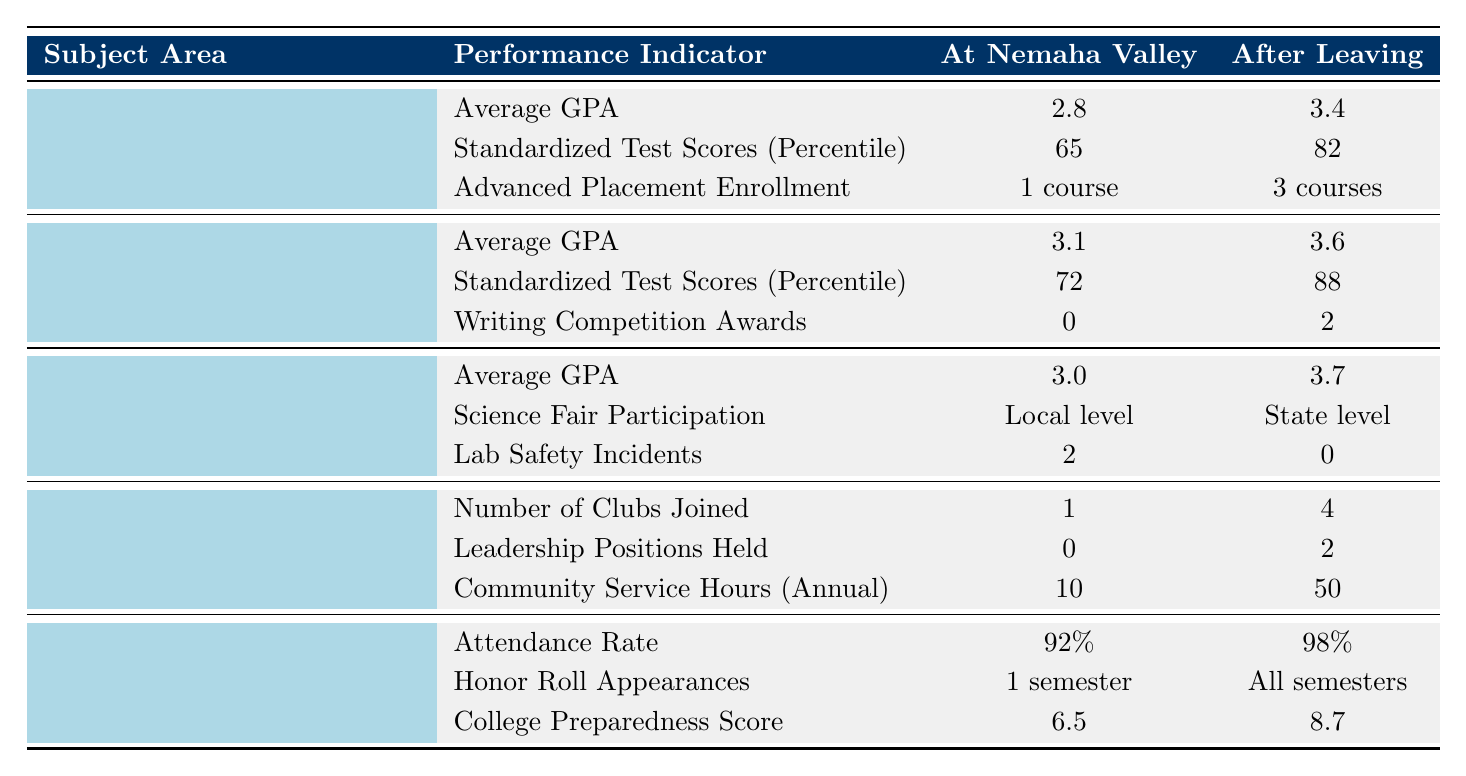What was the Average GPA in Mathematics at Nemaha Valley Schools? The table shows that the Average GPA in Mathematics at Nemaha Valley Schools was 2.8.
Answer: 2.8 What is the percentage increase in Standardized Test Scores for English Language Arts after leaving Nemaha Valley? The scores were 72 at Nemaha Valley and 88 after leaving. The difference is 88 - 72 = 16. The percentage increase is (16 / 72) * 100 = 22.22%.
Answer: 22.22% Did students have more Advanced Placement courses after leaving Nemaha Valley compared to when they were there? The table indicates that students had "1 course" at Nemaha Valley and "3 courses" after leaving. Therefore, students did have more courses after.
Answer: Yes What was the difference in Community Service Hours annually before and after leaving Nemaha Valley? The hours were 10 at Nemaha Valley and 50 after leaving. The difference is 50 - 10 = 40 hours.
Answer: 40 hours How did the average science GPA change after leaving Nemaha Valley? The average GPA in Science was 3.0 at Nemaha Valley and increased to 3.7 after leaving. The change is 3.7 - 3.0 = 0.7.
Answer: 0.7 Was there an increase in the number of clubs joined after leaving Nemaha Valley? The table shows "1" club joined at Nemaha Valley and "4" after leaving, indicating an increase in clubs joined.
Answer: Yes Calculate the total number of awards received in Writing Competitions by students after leaving Nemaha Valley. The table shows that students received "0" awards at Nemaha Valley and "2" after leaving. The total awards after leaving is 2.
Answer: 2 Which subject area had the highest percentage increase in average GPA after leaving Nemaha Valley? The average GPA increased in Mathematics (2.8 to 3.4, an increase of 0.6), English Language Arts (3.1 to 3.6, an increase of 0.5), and Science (3.0 to 3.7, an increase of 0.7). Thus, Science had the highest increase of 0.7.
Answer: Science How many semesters did students appear on the honor roll at Nemaha Valley compared to after leaving? Students appeared for "1 semester" at Nemaha Valley and "All semesters" after leaving, indicating a significant increase.
Answer: 1 semester vs All semesters What was the improvement in the Lab Safety Incidents reported after leaving Nemaha Valley? The number of incidents reported was "2" at Nemaha Valley and "0" after leaving. The improvement is 2 - 0 = 2 fewer incidents.
Answer: 2 fewer incidents 